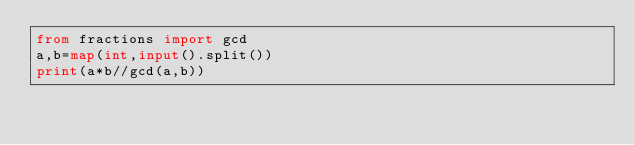Convert code to text. <code><loc_0><loc_0><loc_500><loc_500><_Python_>from fractions import gcd
a,b=map(int,input().split())
print(a*b//gcd(a,b))</code> 